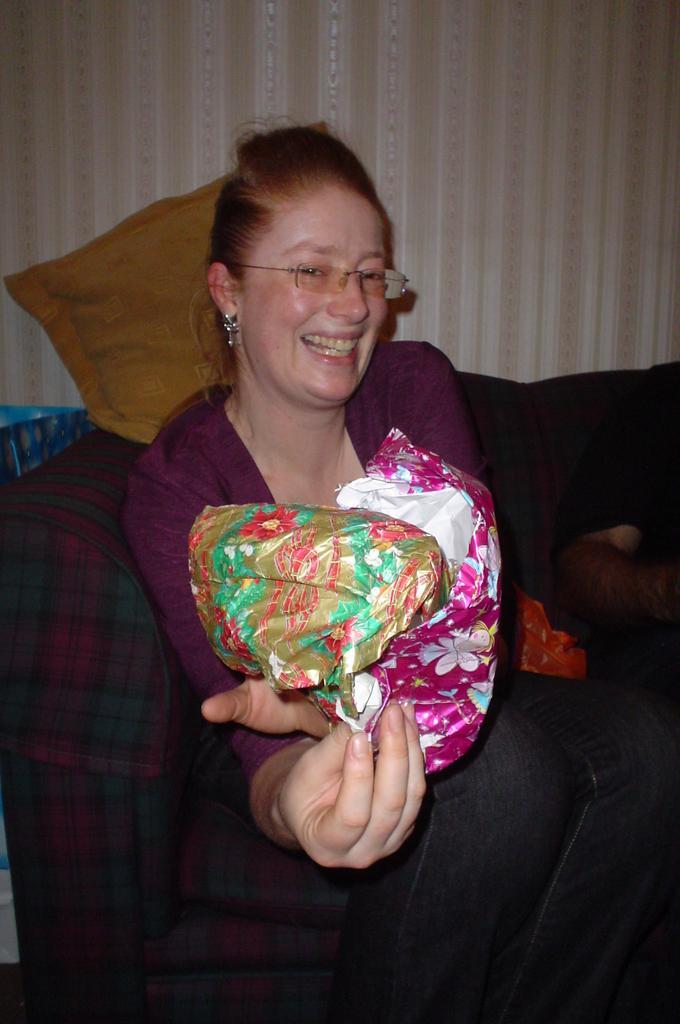How would you summarize this image in a sentence or two? This picture shows a woman seated and she is holding, gift covers in her hand and we see a sofa and a cushion on the back and women wore spectacles and smile on the face and we see a soft toy. 